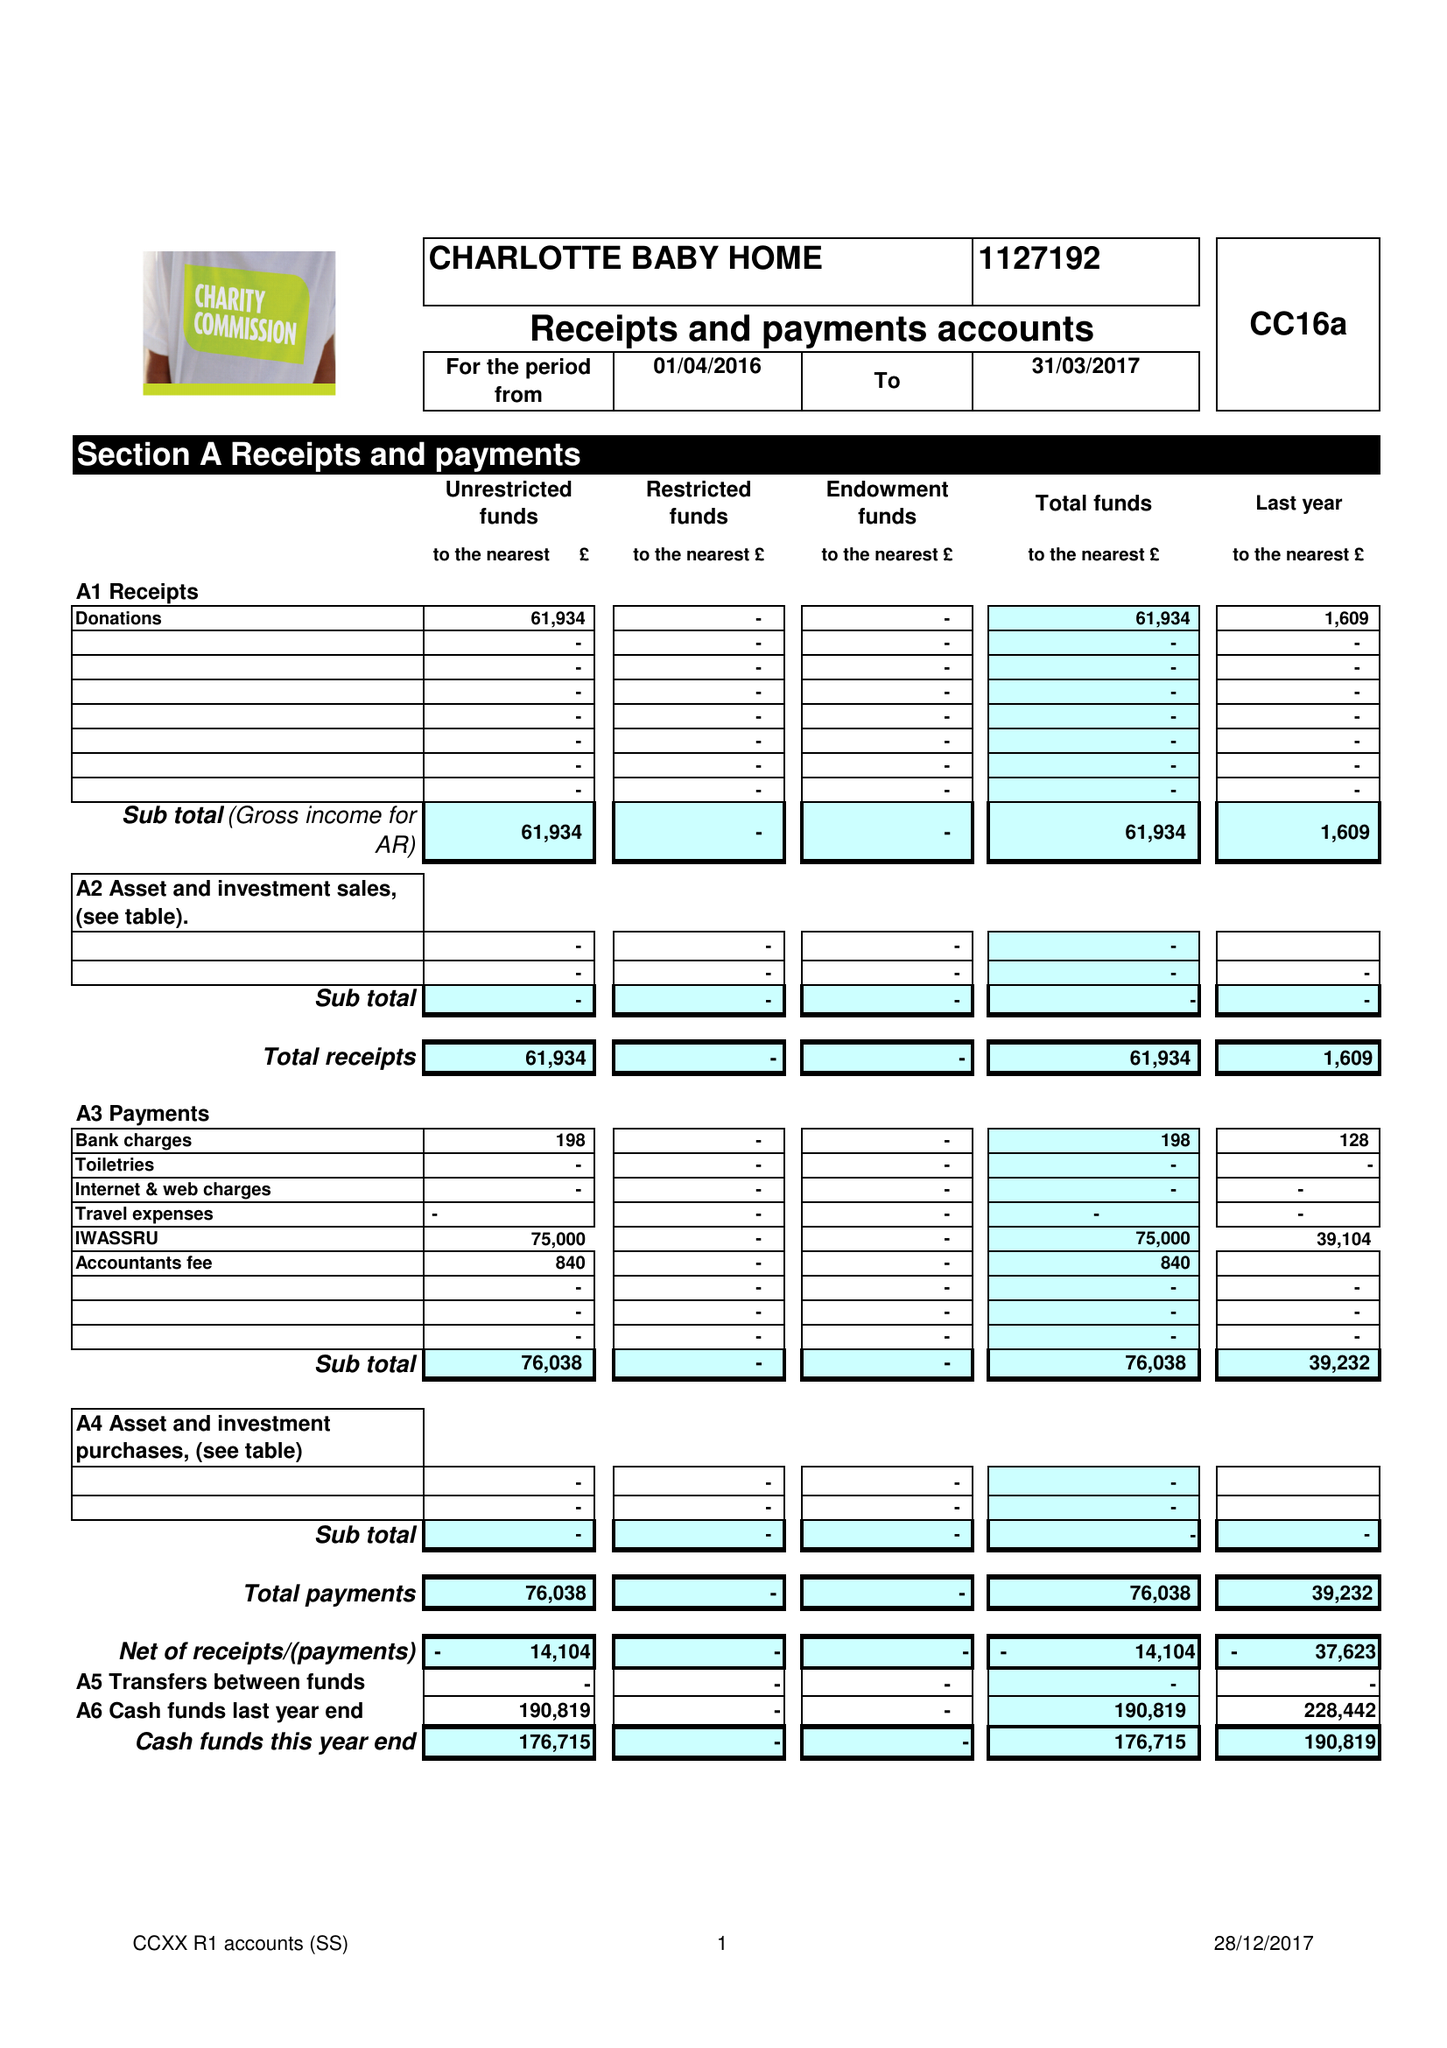What is the value for the address__postcode?
Answer the question using a single word or phrase. EC2V 8EY 